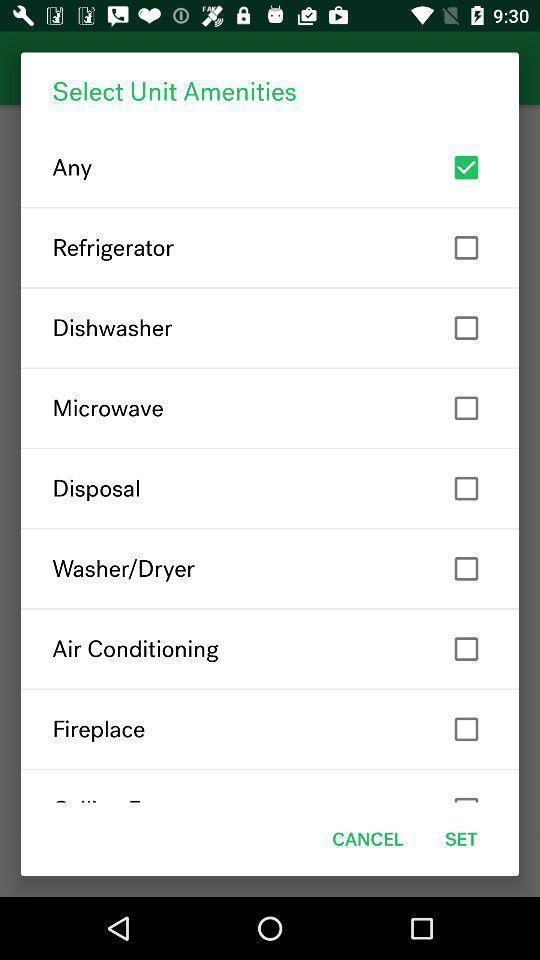Tell me what you see in this picture. Pop-up to select unit amenities. 